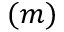Convert formula to latex. <formula><loc_0><loc_0><loc_500><loc_500>( m )</formula> 